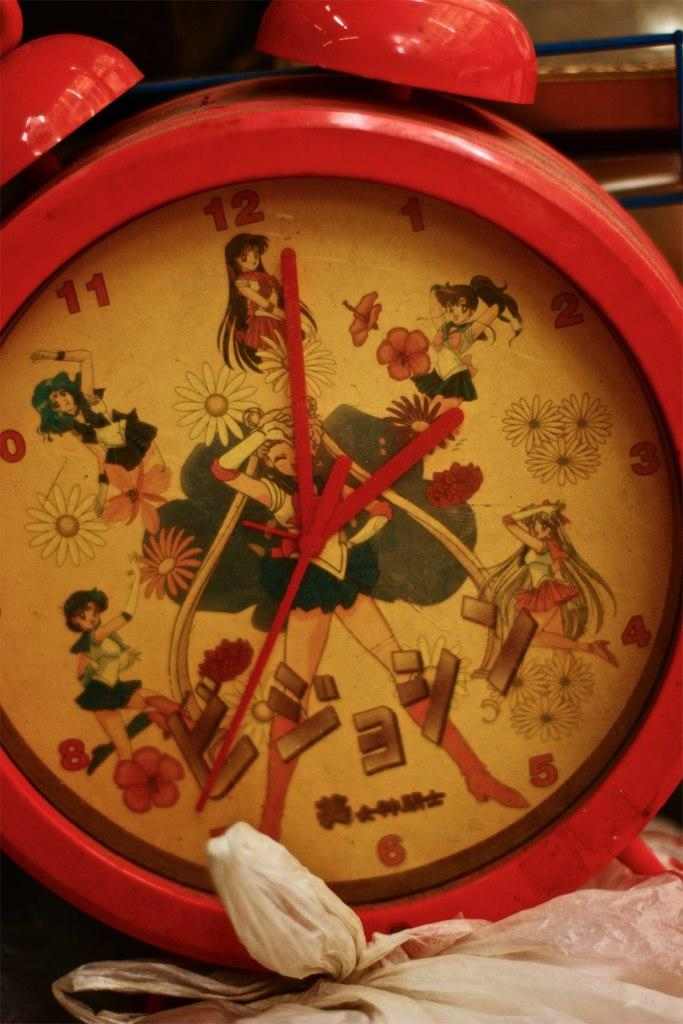<image>
Render a clear and concise summary of the photo. Red clock with anime characters and the number 3 on the face. 